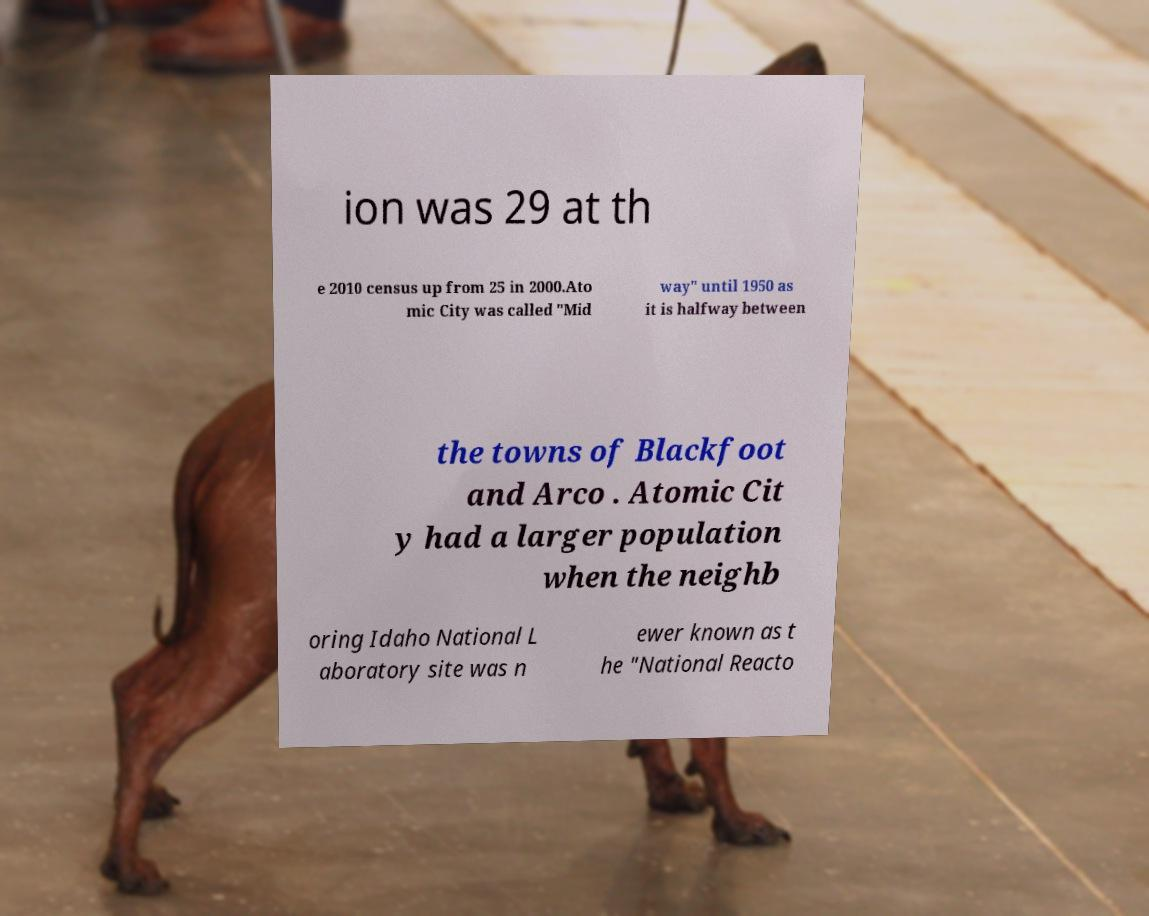Can you read and provide the text displayed in the image?This photo seems to have some interesting text. Can you extract and type it out for me? ion was 29 at th e 2010 census up from 25 in 2000.Ato mic City was called "Mid way" until 1950 as it is halfway between the towns of Blackfoot and Arco . Atomic Cit y had a larger population when the neighb oring Idaho National L aboratory site was n ewer known as t he "National Reacto 